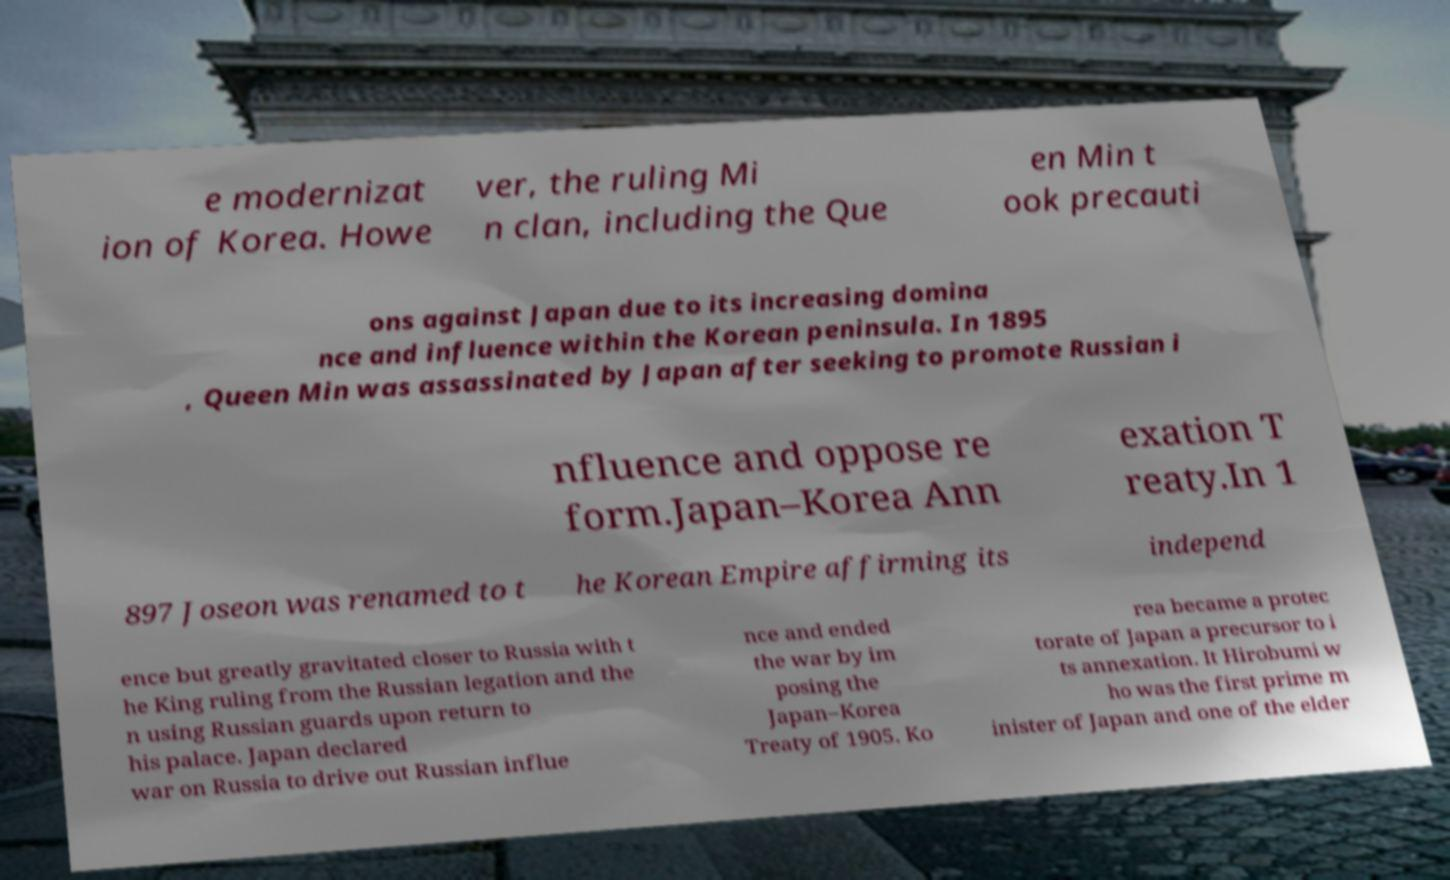For documentation purposes, I need the text within this image transcribed. Could you provide that? e modernizat ion of Korea. Howe ver, the ruling Mi n clan, including the Que en Min t ook precauti ons against Japan due to its increasing domina nce and influence within the Korean peninsula. In 1895 , Queen Min was assassinated by Japan after seeking to promote Russian i nfluence and oppose re form.Japan–Korea Ann exation T reaty.In 1 897 Joseon was renamed to t he Korean Empire affirming its independ ence but greatly gravitated closer to Russia with t he King ruling from the Russian legation and the n using Russian guards upon return to his palace. Japan declared war on Russia to drive out Russian influe nce and ended the war by im posing the Japan–Korea Treaty of 1905. Ko rea became a protec torate of Japan a precursor to i ts annexation. It Hirobumi w ho was the first prime m inister of Japan and one of the elder 